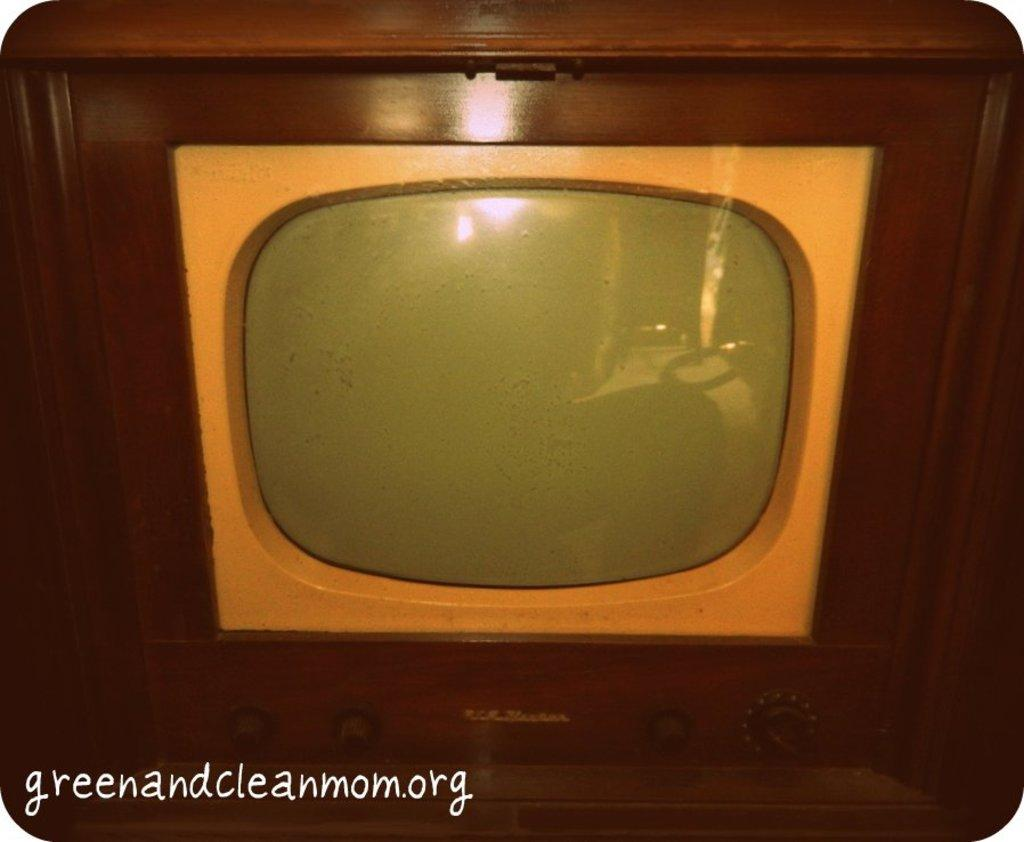What electronic device is present in the image? There is a television in the image. What additional information can be found at the bottom of the image? There is text at the bottom of the image. Is there a slave depicted in the image? No, there is no depiction of a slave in the image. What type of harmony is being portrayed in the image? The image does not depict any specific type of harmony; it features a television and text. 